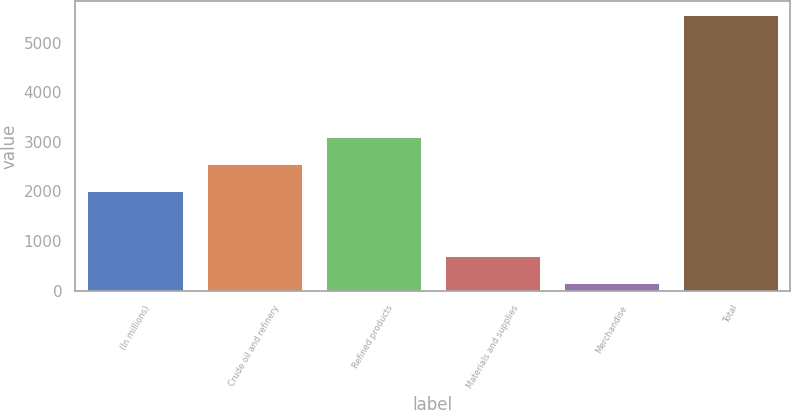Convert chart to OTSL. <chart><loc_0><loc_0><loc_500><loc_500><bar_chart><fcel>(In millions)<fcel>Crude oil and refinery<fcel>Refined products<fcel>Materials and supplies<fcel>Merchandise<fcel>Total<nl><fcel>2017<fcel>2555.9<fcel>3094.8<fcel>699.9<fcel>161<fcel>5550<nl></chart> 